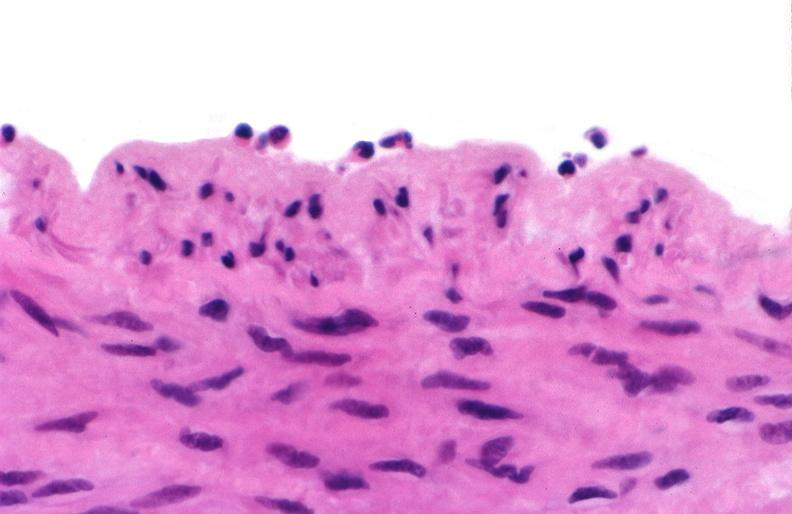s very good example present?
Answer the question using a single word or phrase. No 